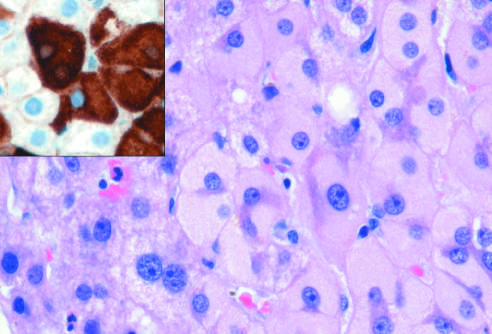s characteristic peribronchial noncaseating granulomas with many giant cells caused by accumulation of hepatitis b surface antigen?
Answer the question using a single word or phrase. No 